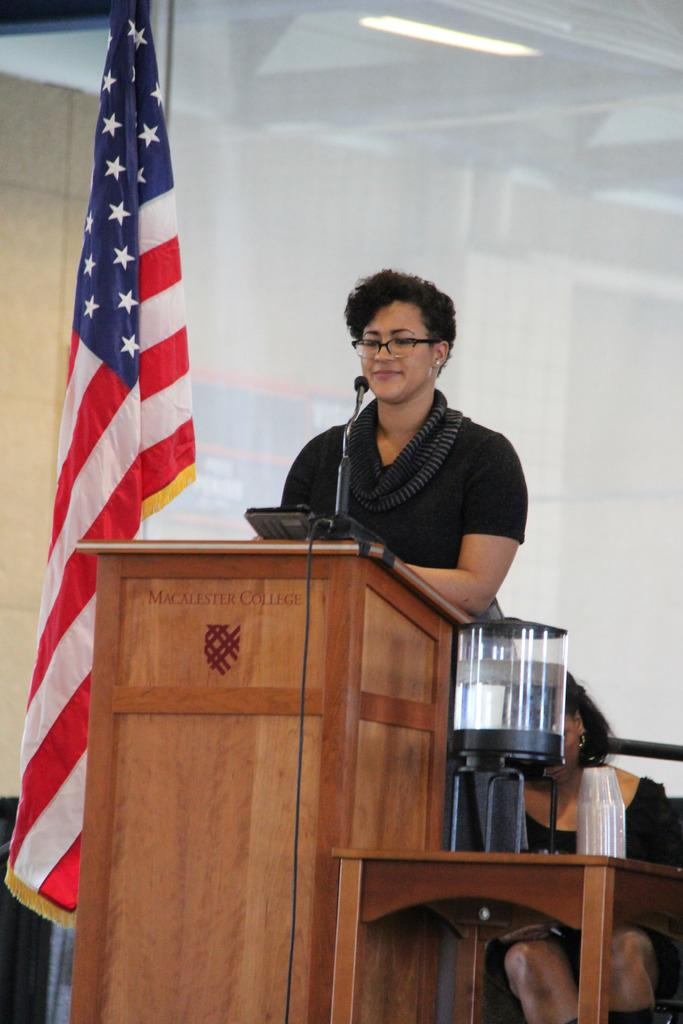<image>
Offer a succinct explanation of the picture presented. a woman at a podium in front of a stars and stripes flag with Macallester 